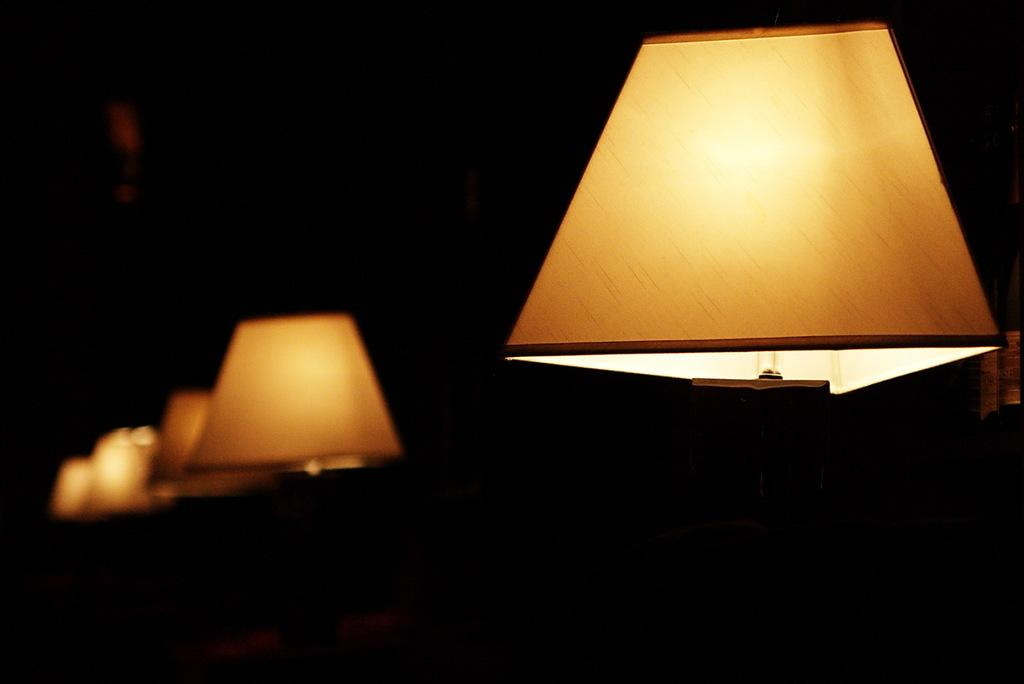What type of objects can be seen in the image? There are lamps in the image. Can you describe the lamps in more detail? Unfortunately, the provided facts do not offer more details about the lamps. Are there any other objects or elements in the image besides the lamps? The given facts do not mention any other objects or elements in the image. How many rings are visible on the lamps in the image? There are no rings mentioned or visible on the lamps in the image. Can you describe the paper that the lamps are requesting in the image? There is no paper or request mentioned or visible in the image. 